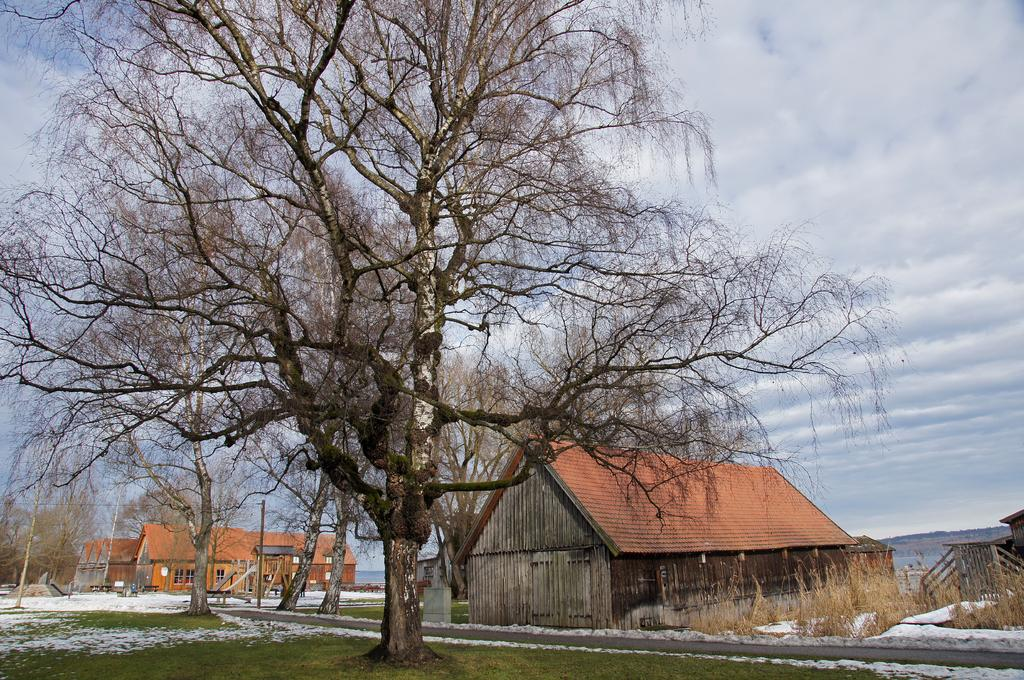What type of vegetation can be seen in the image? There are trees and plants in the image. What type of structures are present in the image? There are buildings in the image. What is the ground covered with in the image? There is grass in the image. What can be seen in the background of the image? The sky is visible in the background of the image, along with other objects on the ground. What thought is being expressed by the tree in the image? Trees do not have the ability to express thoughts, so this cannot be determined from the image. 